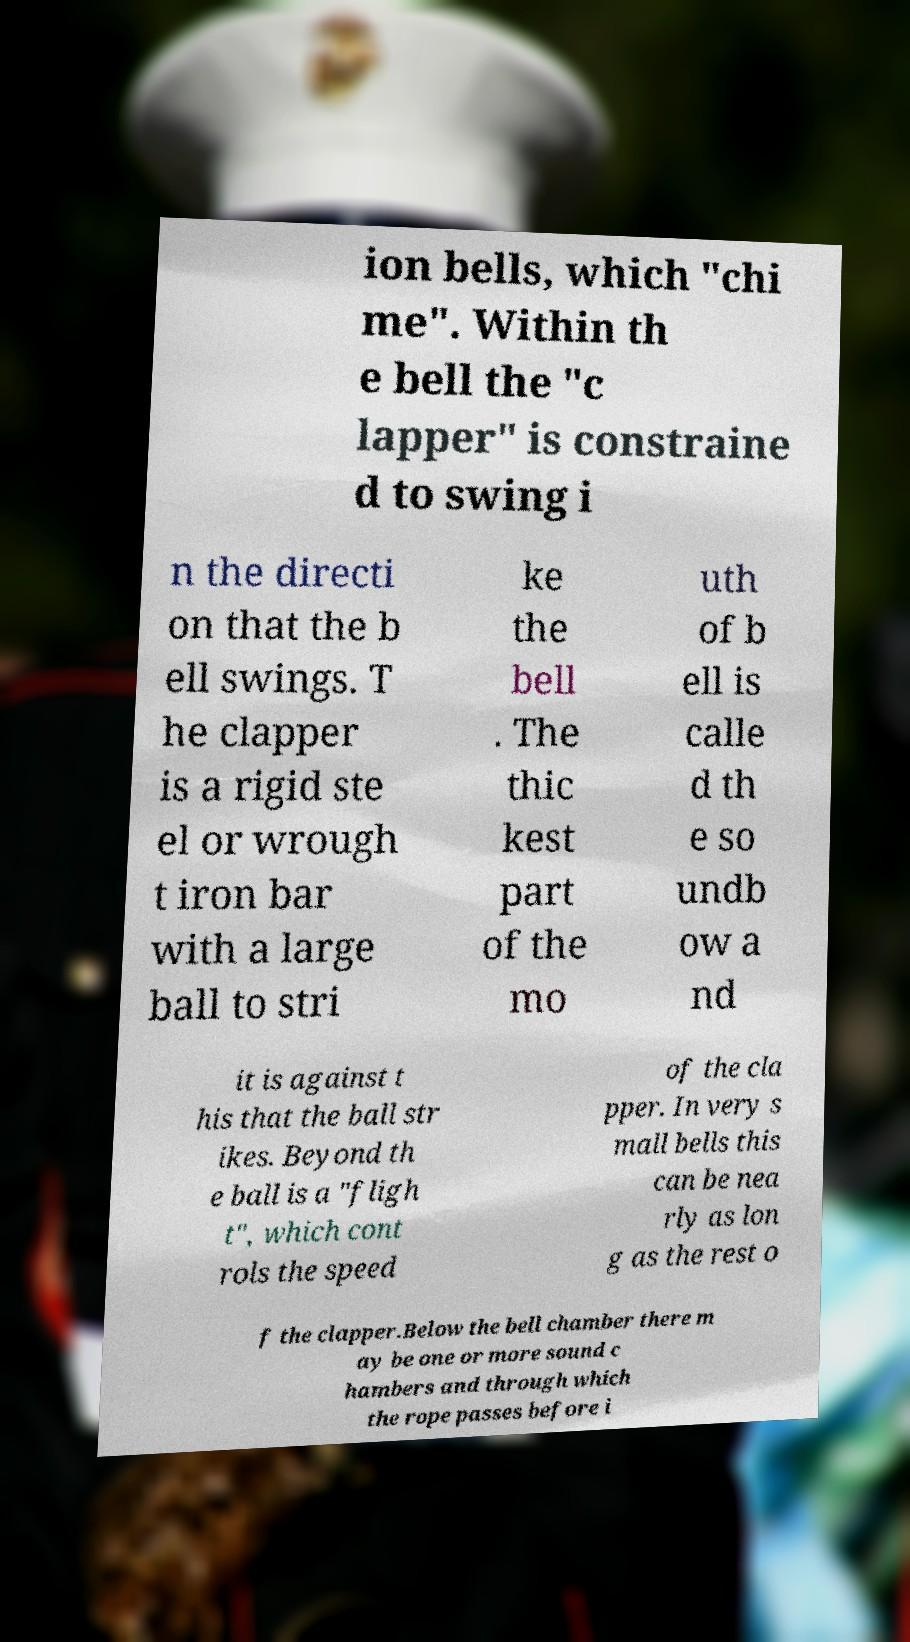Please read and relay the text visible in this image. What does it say? ion bells, which "chi me". Within th e bell the "c lapper" is constraine d to swing i n the directi on that the b ell swings. T he clapper is a rigid ste el or wrough t iron bar with a large ball to stri ke the bell . The thic kest part of the mo uth of b ell is calle d th e so undb ow a nd it is against t his that the ball str ikes. Beyond th e ball is a "fligh t", which cont rols the speed of the cla pper. In very s mall bells this can be nea rly as lon g as the rest o f the clapper.Below the bell chamber there m ay be one or more sound c hambers and through which the rope passes before i 